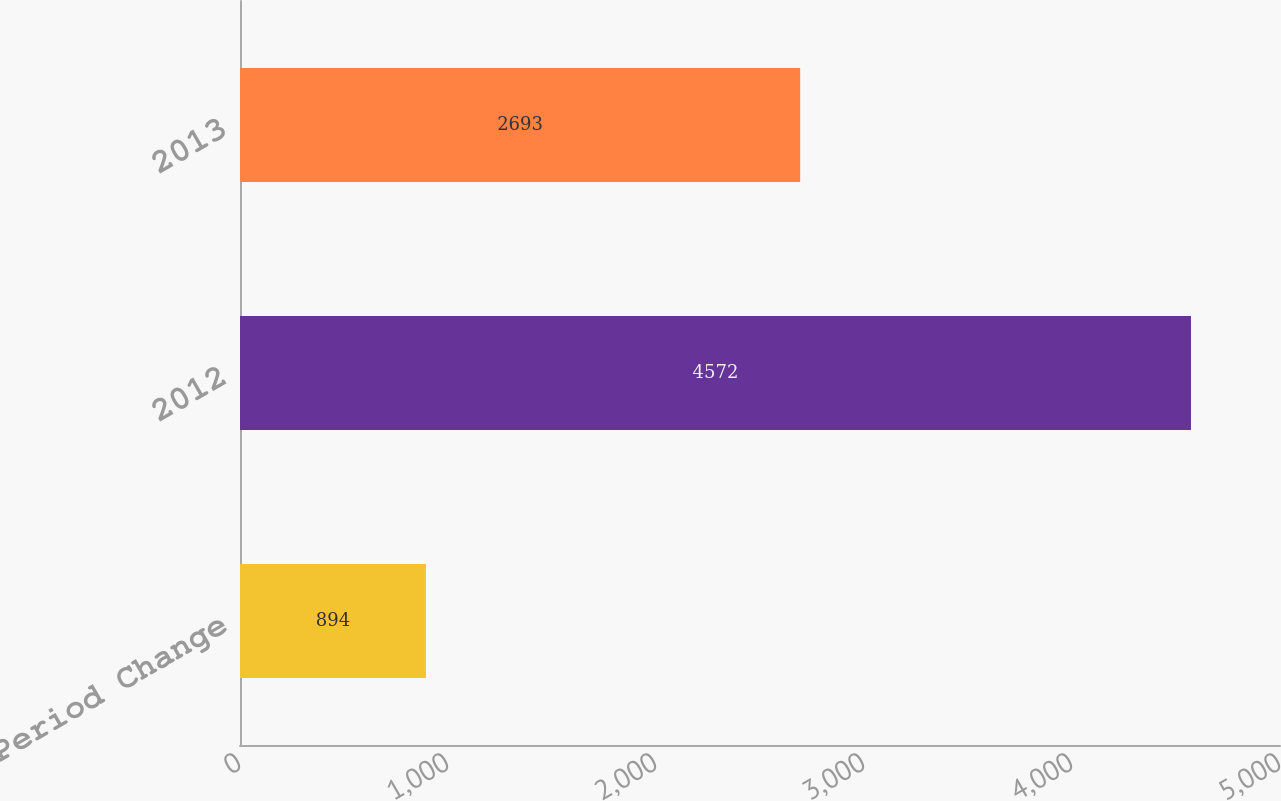Convert chart. <chart><loc_0><loc_0><loc_500><loc_500><bar_chart><fcel>Period Change<fcel>2012<fcel>2013<nl><fcel>894<fcel>4572<fcel>2693<nl></chart> 